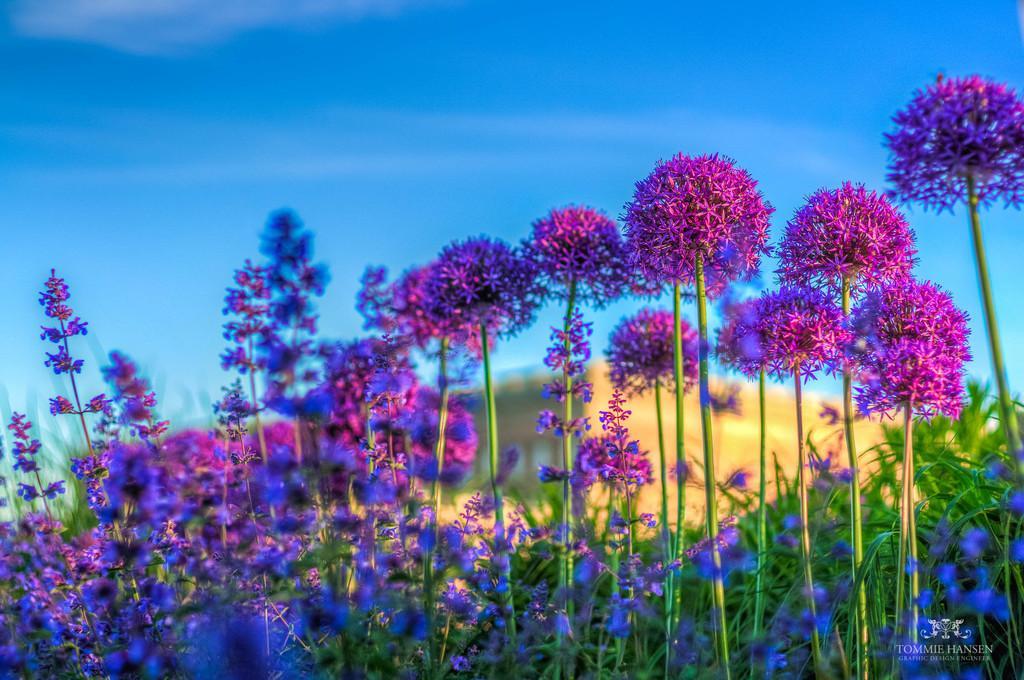Describe this image in one or two sentences. In this image I can see some flowers. In the background, I can see the clouds in the sky. 